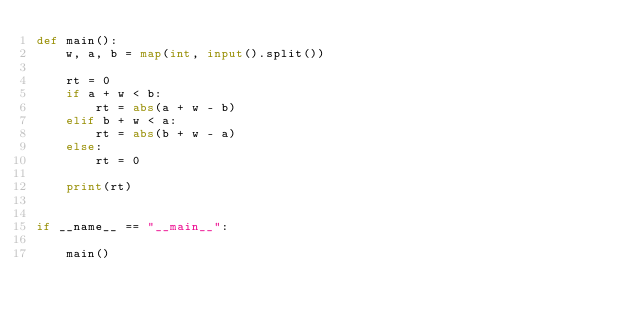<code> <loc_0><loc_0><loc_500><loc_500><_Python_>def main():
    w, a, b = map(int, input().split())

    rt = 0
    if a + w < b:
        rt = abs(a + w - b)
    elif b + w < a:
        rt = abs(b + w - a)
    else:
        rt = 0

    print(rt)


if __name__ == "__main__":

    main()
</code> 